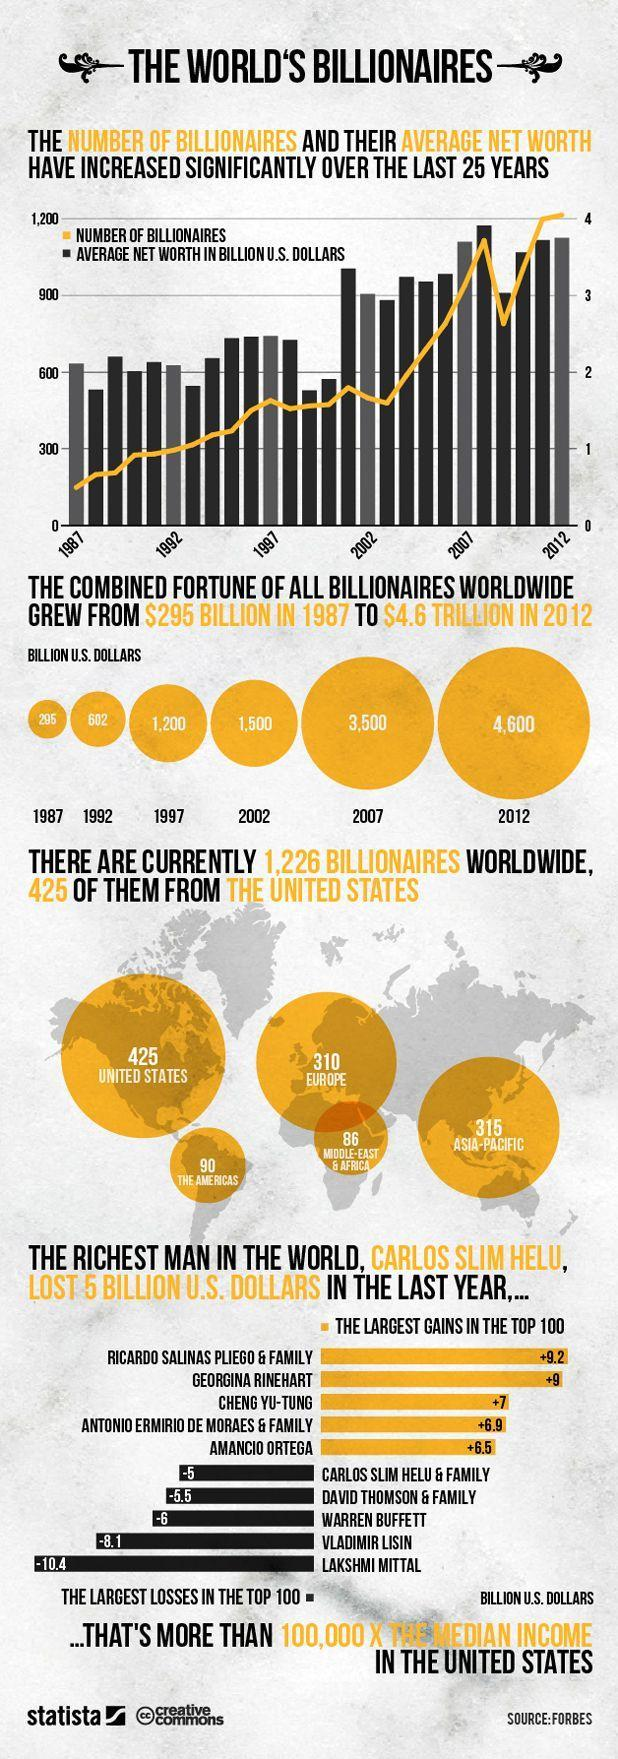What is the number of billionaires in the United States and Asia-Pacific, taken together?
Answer the question with a short phrase. 740 